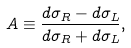<formula> <loc_0><loc_0><loc_500><loc_500>A \equiv \frac { d \sigma _ { R } - d \sigma _ { L } } { d \sigma _ { R } + d \sigma _ { L } } ,</formula> 